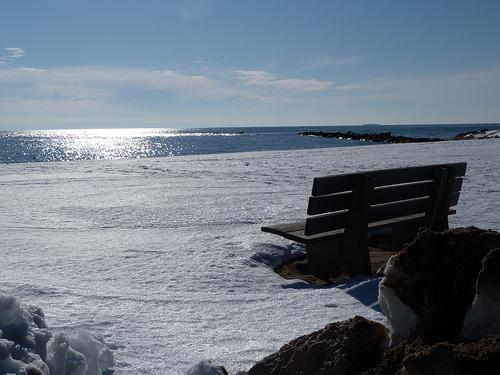How many benches are on the beach?
Give a very brief answer. 1. 